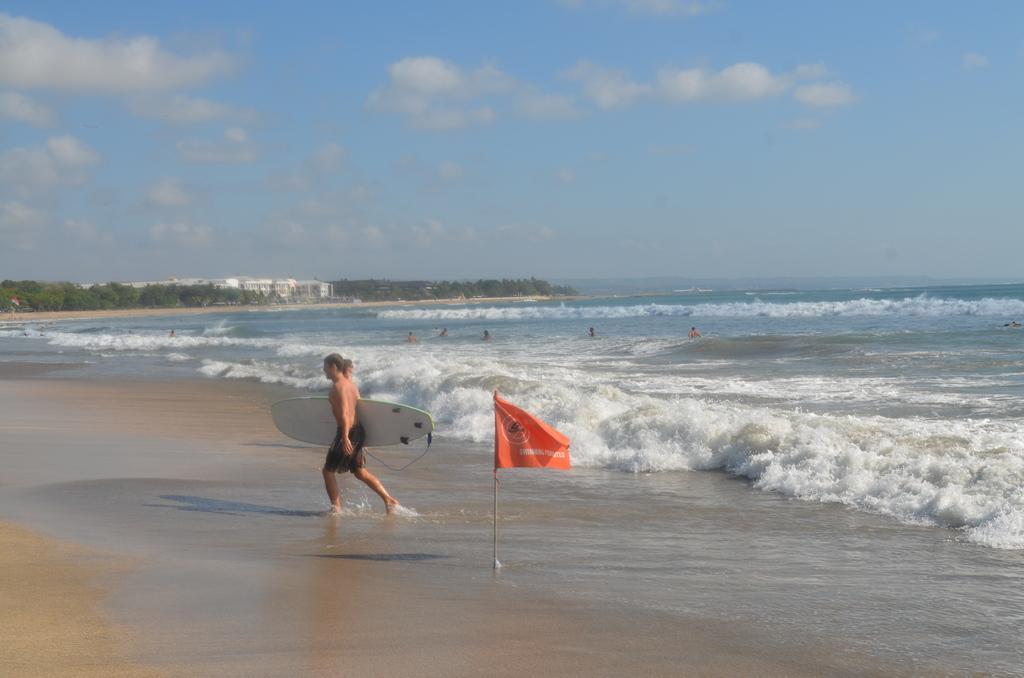Please provide a concise description of this image. He is walking. He's holding a skateboard. We can see in the background there is a sea,sky and trees. 